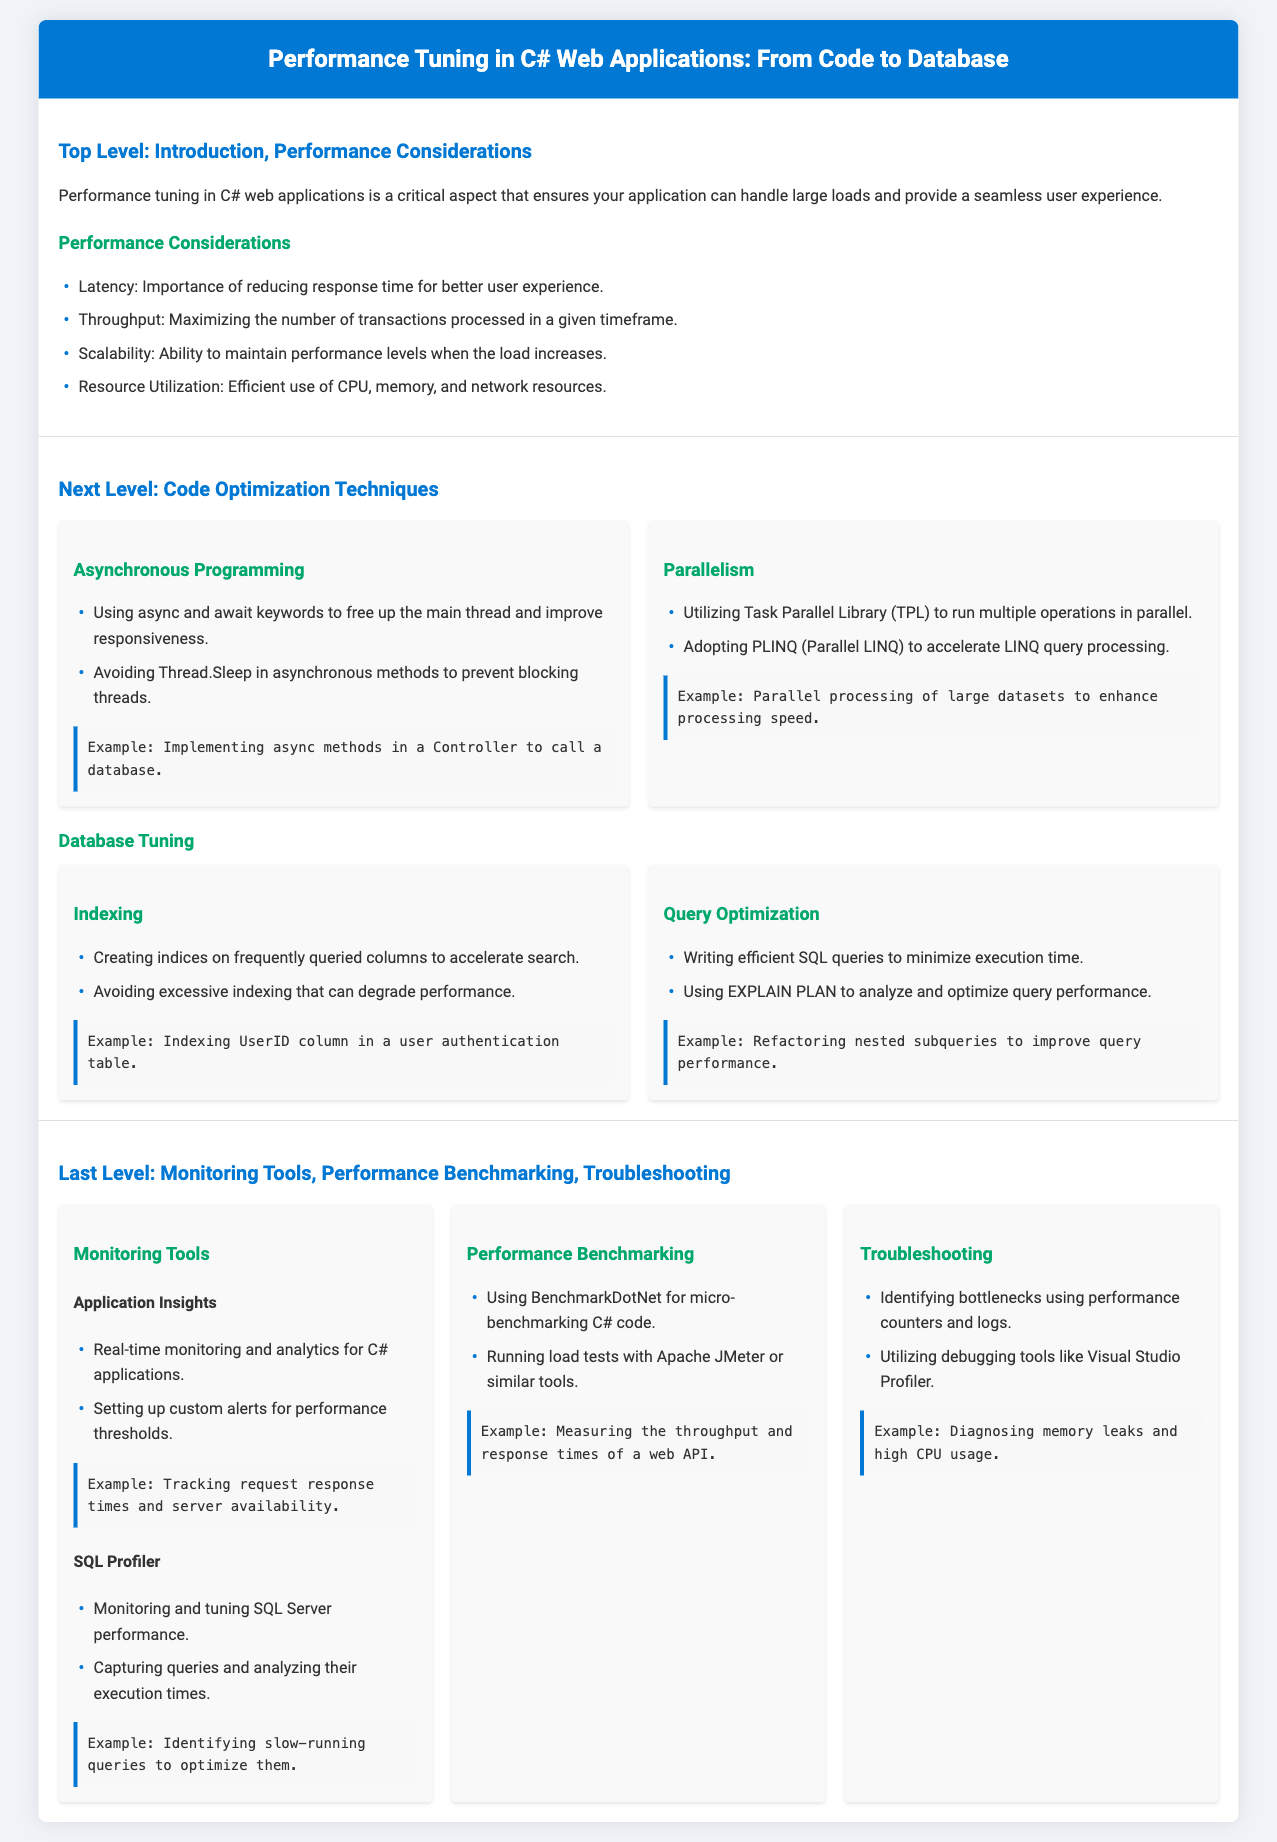What are the four performance considerations? The four performance considerations are listed in the document under Performance Considerations.
Answer: Latency, Throughput, Scalability, Resource Utilization What is the main benefit of asynchronous programming? The main benefit is described as freeing up the main thread and improving responsiveness.
Answer: Improving responsiveness What is one technique used for database tuning? The document lists various techniques under Database Tuning, one of which is indexing.
Answer: Indexing What tool is used for micro-benchmarking C# code? The document specifies BenchmarkDotNet as a tool for micro-benchmarking.
Answer: BenchmarkDotNet Which keyword is associated with asynchronous programming? The keywords associated with asynchronous programming are identified in the techniques section.
Answer: async and await What does SQL Profiler monitor? The document states that SQL Profiler monitors SQL Server performance.
Answer: SQL Server performance What is the purpose of using EXPLAIN PLAN? The purpose is to analyze and optimize query performance.
Answer: Optimize query performance What functionality does Application Insights provide? The functionality of Application Insights is outlined as real-time monitoring and analytics.
Answer: Real-time monitoring and analytics What can be used to identify memory leaks? The document mentions utilizing debugging tools specifically for diagnosing memory issues.
Answer: Visual Studio Profiler 